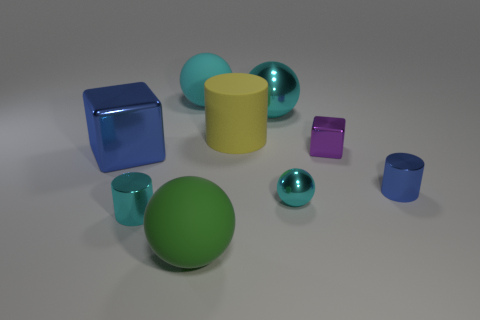What is the size of the rubber thing that is behind the green rubber sphere and on the left side of the large matte cylinder?
Offer a very short reply. Large. Are there any cyan balls that have the same size as the green rubber thing?
Provide a short and direct response. Yes. Is the number of metallic cylinders on the right side of the purple object greater than the number of yellow matte objects that are in front of the small blue metallic cylinder?
Your answer should be very brief. Yes. Do the blue cube and the cylinder behind the tiny purple metallic object have the same material?
Make the answer very short. No. There is a metal block that is to the left of the large object on the right side of the large cylinder; what number of large cyan matte things are in front of it?
Provide a succinct answer. 0. There is a small blue metal object; is its shape the same as the matte object that is in front of the tiny purple thing?
Provide a short and direct response. No. What color is the large thing that is both in front of the tiny purple thing and behind the green sphere?
Give a very brief answer. Blue. There is a small cylinder right of the big yellow thing that is left of the small shiny thing that is to the right of the purple shiny cube; what is its material?
Keep it short and to the point. Metal. What is the purple thing made of?
Your answer should be compact. Metal. There is a blue object that is the same shape as the big yellow rubber thing; what size is it?
Your answer should be very brief. Small. 